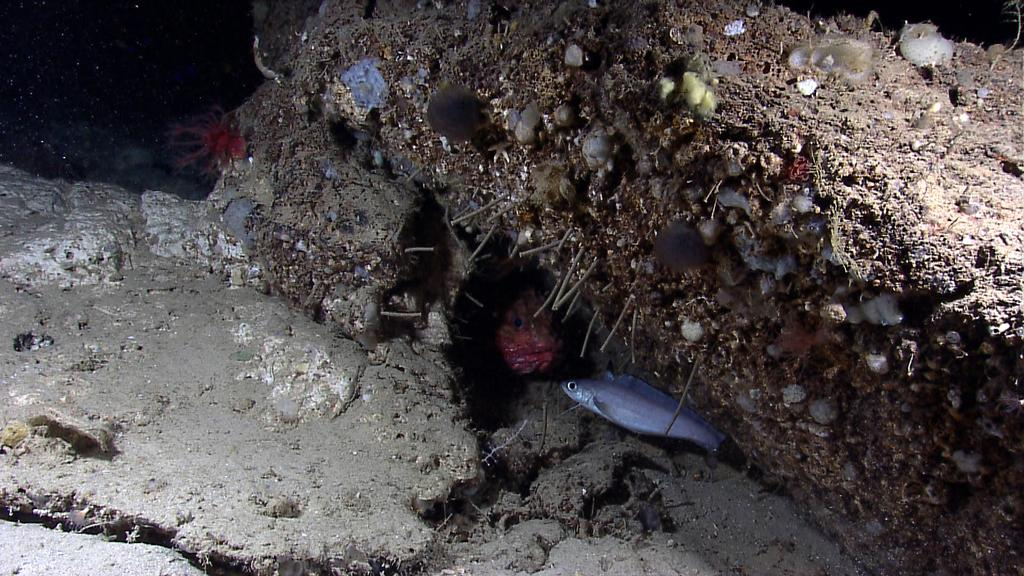What type of animals can be seen in the water in the image? There are fish in the water in the image. What type of terrain is visible in the image? There is soil visible in the image. What activity is the fish participating in the image? The image does not depict any specific activity that the fish are participating in. What type of test is being conducted on the soil in the image? There is no test being conducted on the soil in the image; it is simply visible in the image. 